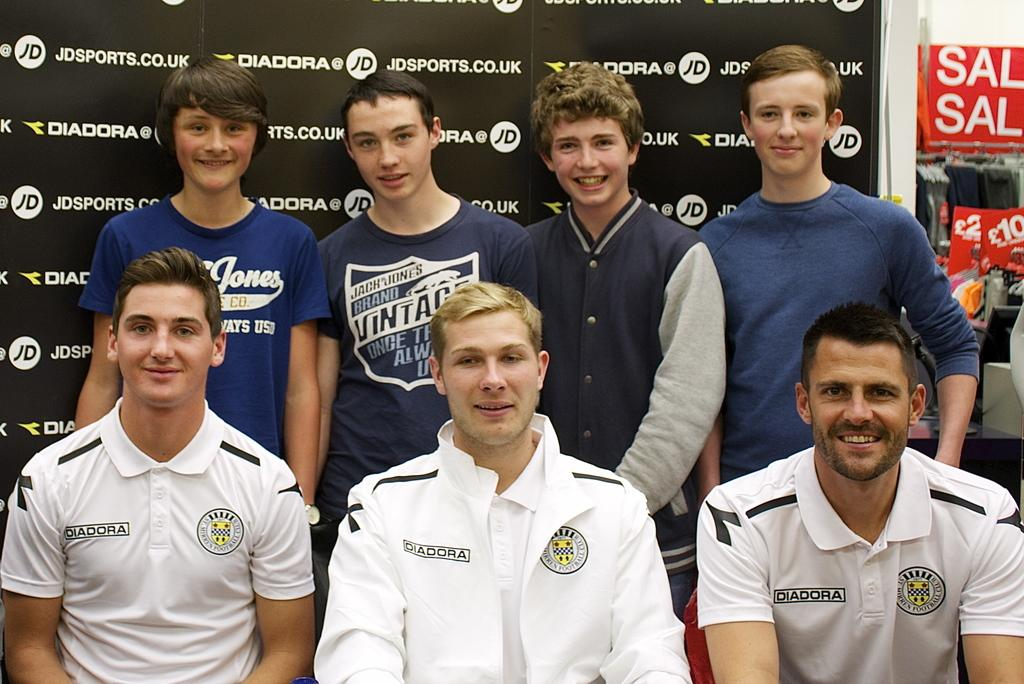<image>
Describe the image concisely. a person that wears a vintage shirt that is blue 